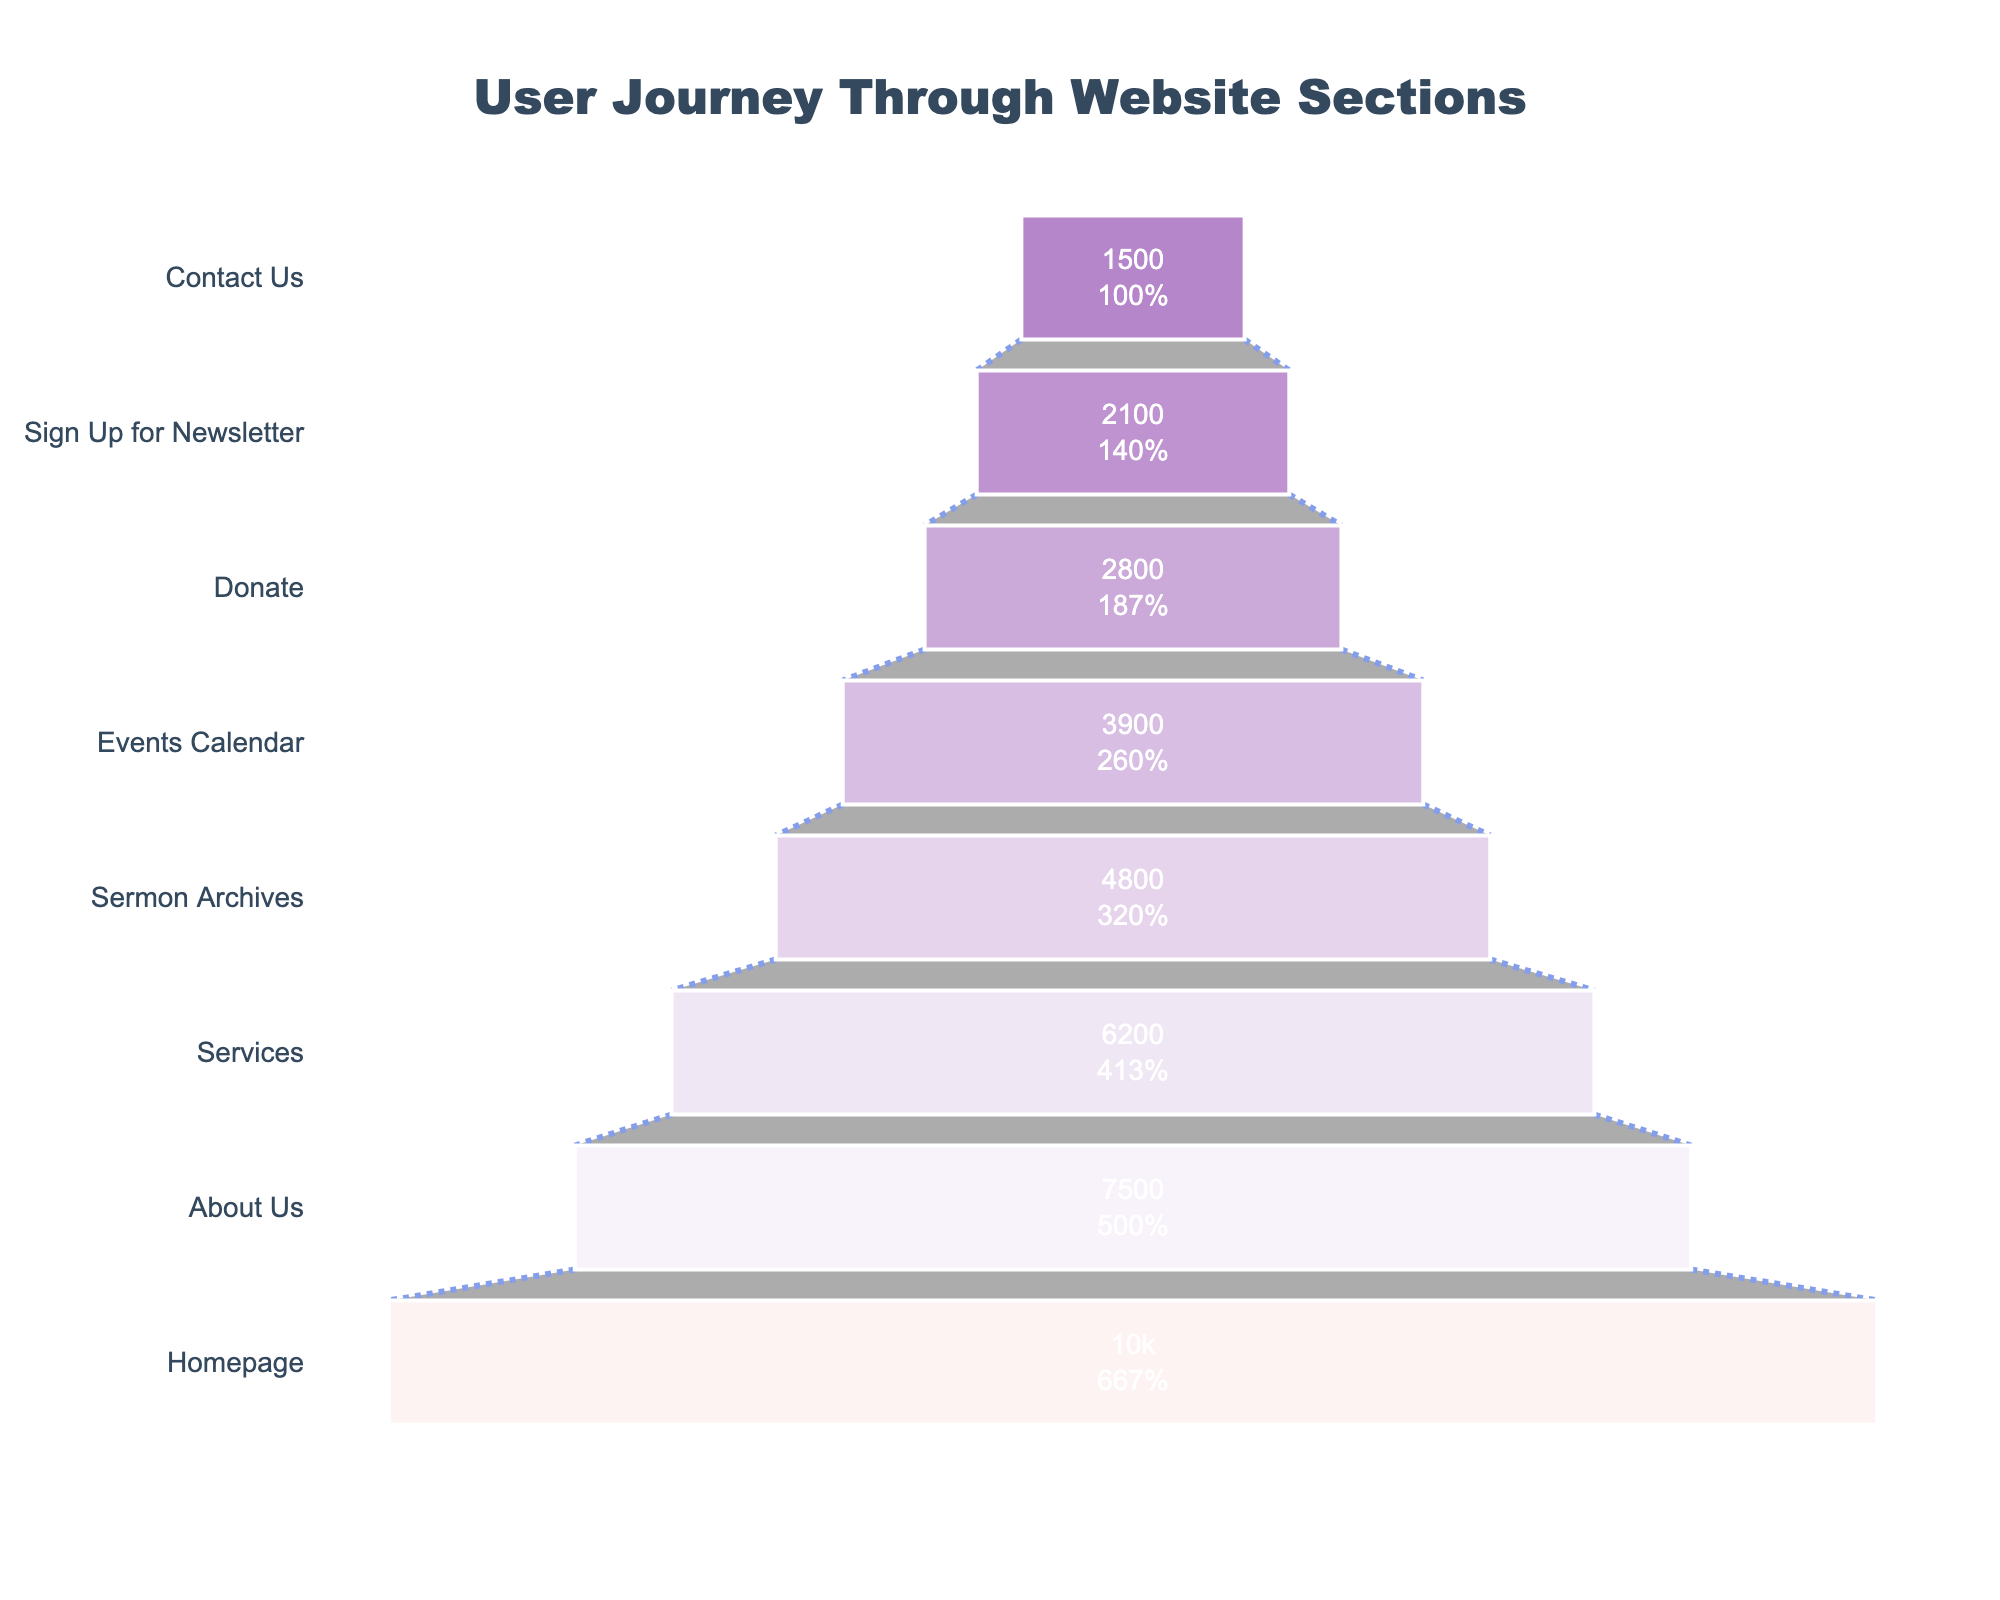What's the title of the funnel chart? Examine the top of the funnel chart to find the title, which is centrally aligned in a larger font and different color.
Answer: User Journey Through Website Sections How many users visit the "Services" section? Locate the "Services" stage in the funnel and read the corresponding user count info.
Answer: 6200 Which section has the largest drop in users compared to its previous stage? Calculate the difference in user counts for each stage compared to its preceding stage, and identify the stage with the largest drop.
Answer: Donate How many users leave the website between the "Homepage" and "Donate" sections? Sum the differences in user counts between each consecutive stage from "Homepage" to "Donate".
Answer: 7200 What is the percentage of users retained from the "Sermon Archives" to "Events Calendar" sections? Divide the number of users at "Events Calendar" by the number of users at "Sermon Archives" and multiply by 100 to get the retention percentage.
Answer: 81.25% Which stage has the highest retention rate from the previous stage? Calculate the retention rates for each stage by dividing the user count at each stage by the user count at the previous stage, then identify the highest retention rate.
Answer: Sign Up for Newsletter 